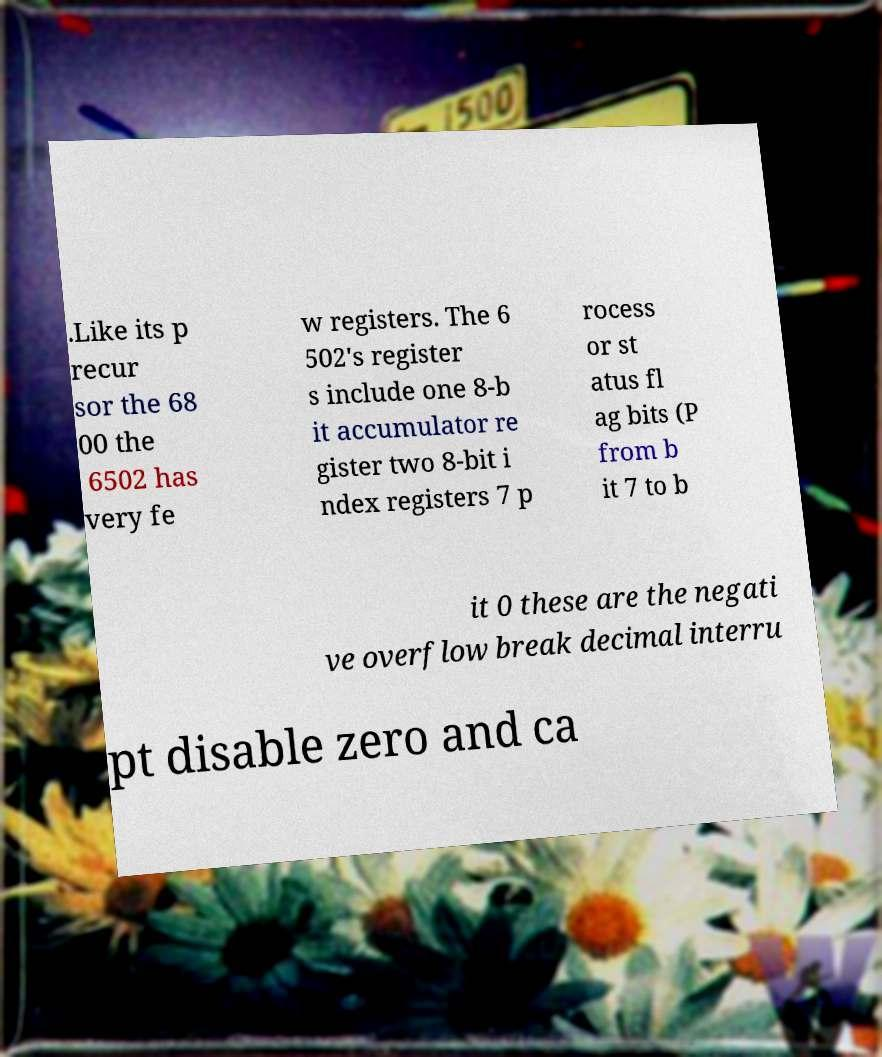Can you read and provide the text displayed in the image?This photo seems to have some interesting text. Can you extract and type it out for me? .Like its p recur sor the 68 00 the 6502 has very fe w registers. The 6 502's register s include one 8-b it accumulator re gister two 8-bit i ndex registers 7 p rocess or st atus fl ag bits (P from b it 7 to b it 0 these are the negati ve overflow break decimal interru pt disable zero and ca 